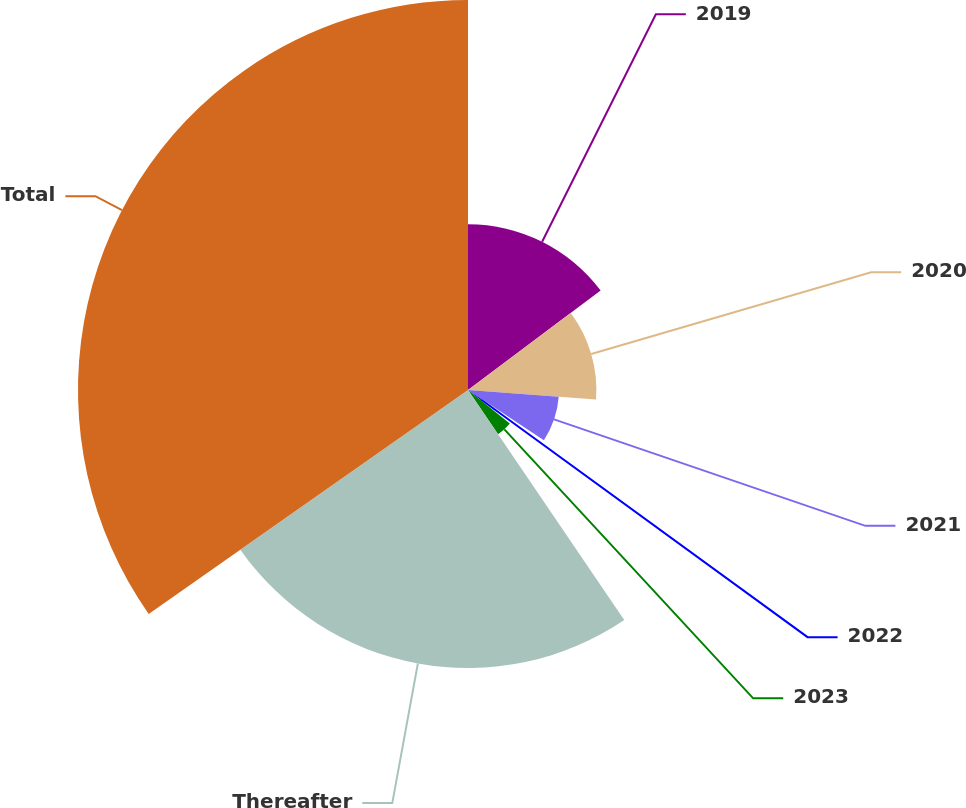Convert chart to OTSL. <chart><loc_0><loc_0><loc_500><loc_500><pie_chart><fcel>2019<fcel>2020<fcel>2021<fcel>2022<fcel>2023<fcel>Thereafter<fcel>Total<nl><fcel>14.76%<fcel>11.43%<fcel>8.1%<fcel>1.44%<fcel>4.77%<fcel>24.76%<fcel>34.73%<nl></chart> 